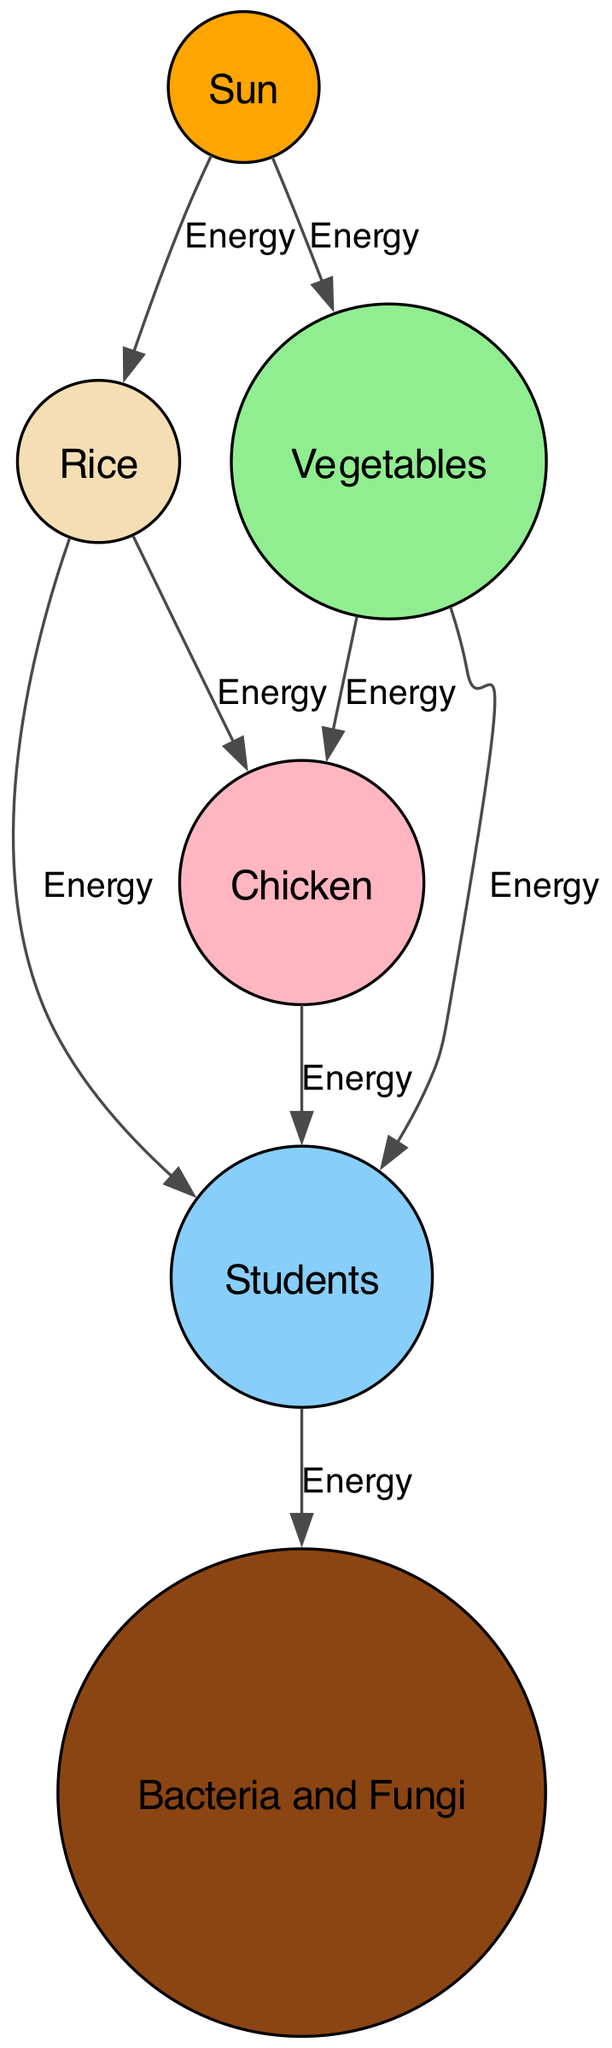What is the first element that provides energy in this food chain? The food chain starts with the Sun, which is positioned at the top and is the source of energy for the entire ecosystem.
Answer: Sun How many nodes are there in the diagram? To find the total nodes, count each unique element: Sun, Rice, Vegetables, Chicken, Students, and Decomposers, which totals 6 nodes.
Answer: 6 Which two elements directly consume Rice? The diagram shows that Chicken and Students both receive energy directly from Rice, connected by arrows from Rice to each element.
Answer: Chicken and Students What role do Decomposers play in this food chain? Decomposers receive energy from Students, which indicates they break down organic material from students after consumption, playing a critical recycling role in the ecosystem.
Answer: Energy recycling How many energy flows are there from Vegetables? Count the arrows originating from Vegetables: It flows to Chicken and Students, which results in 2 distinct energy transfers from Vegetables.
Answer: 2 Which element is at the top of the food chain? The Sun is positioned at the top, representing the primary energy source in the food chain, illuminating its foundational role.
Answer: Sun What is the relationship between Chicken and Students in terms of energy? Chicken provides energy to Students, indicating that Students may consume Chicken as part of their lunch, creating a direct consumer relationship in the chain.
Answer: Energy source What element receives energy from both Rice and Vegetables? The Chicken receives energy from both Rice and Vegetables, as shown by the connections from these two elements leading directly to Chicken.
Answer: Chicken Which element is a producer in the food chain? Both Rice and Vegetables are producers since they convert energy from the Sun into food for other organisms through photosynthesis, as indicated in the diagram.
Answer: Rice and Vegetables 